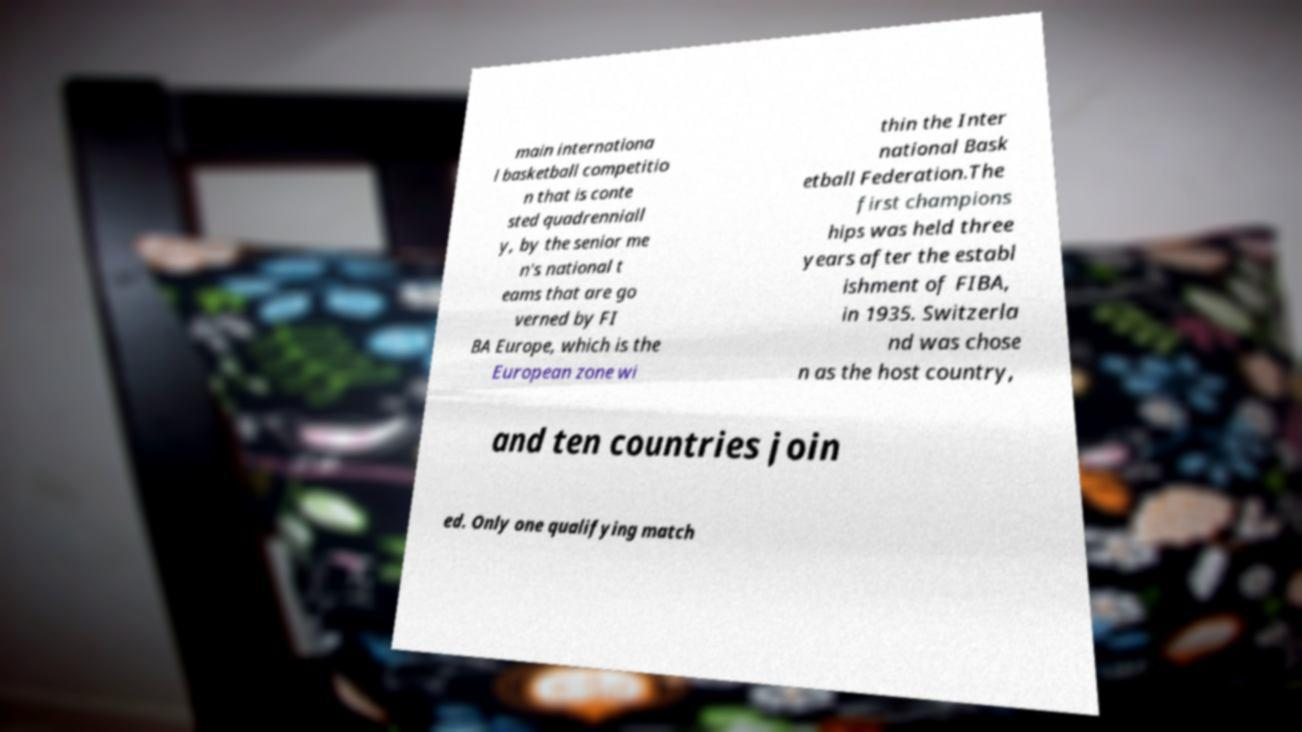Could you assist in decoding the text presented in this image and type it out clearly? main internationa l basketball competitio n that is conte sted quadrenniall y, by the senior me n's national t eams that are go verned by FI BA Europe, which is the European zone wi thin the Inter national Bask etball Federation.The first champions hips was held three years after the establ ishment of FIBA, in 1935. Switzerla nd was chose n as the host country, and ten countries join ed. Only one qualifying match 